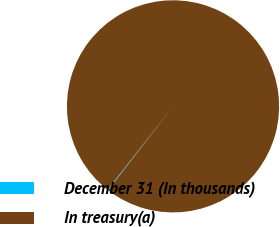Convert chart to OTSL. <chart><loc_0><loc_0><loc_500><loc_500><pie_chart><fcel>December 31 (In thousands)<fcel>In treasury(a)<nl><fcel>0.12%<fcel>99.88%<nl></chart> 